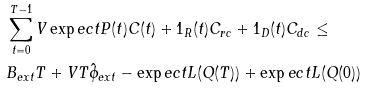Convert formula to latex. <formula><loc_0><loc_0><loc_500><loc_500>& \sum _ { t = 0 } ^ { T - 1 } V \exp e c t { P ( t ) C ( t ) + 1 _ { R } ( t ) C _ { r c } + 1 _ { D } ( t ) C _ { d c } } \leq \\ & B _ { e x t } T + V T \hat { \phi } _ { e x t } - \exp e c t { L ( Q ( T ) ) } + \exp e c t { L ( Q ( 0 ) ) }</formula> 